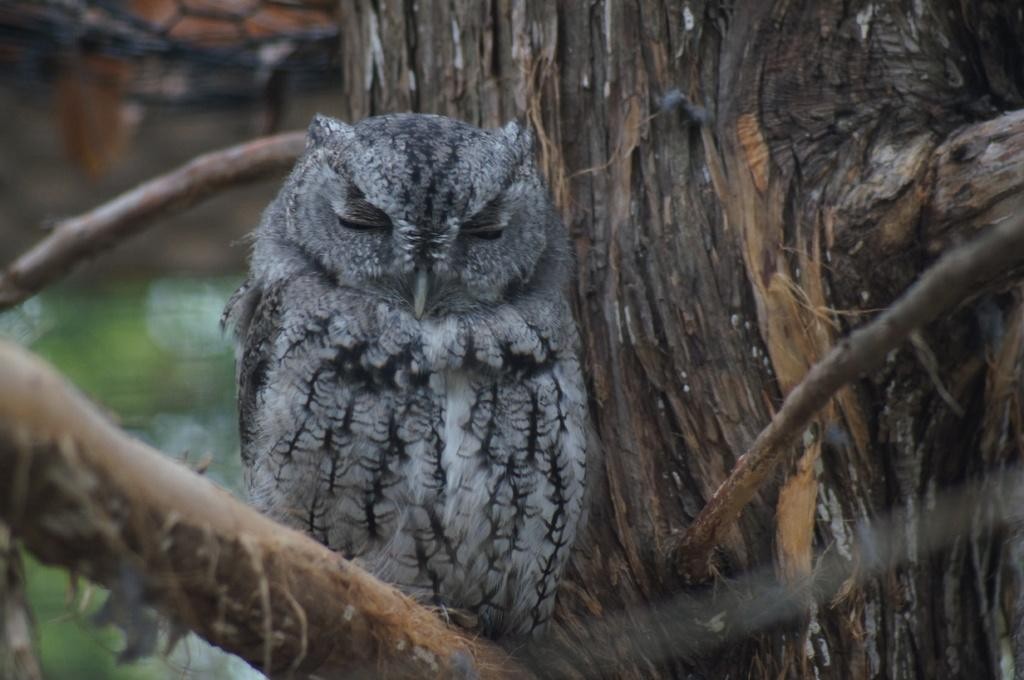What animal is present in the image? There is an owl in the image. What colors are used to depict the owl? The owl is in a black and gray color combination. Where is the owl positioned in the image? The owl is standing on the branch of a tree. What can be seen in the background of the image? There is water visible in the background of the image, along with other objects. Can you see any keys hanging from the tree branch where the owl is standing? No, there are no keys visible in the image. Are there any fairies flying around the owl in the image? No, there are no fairies present in the image. 